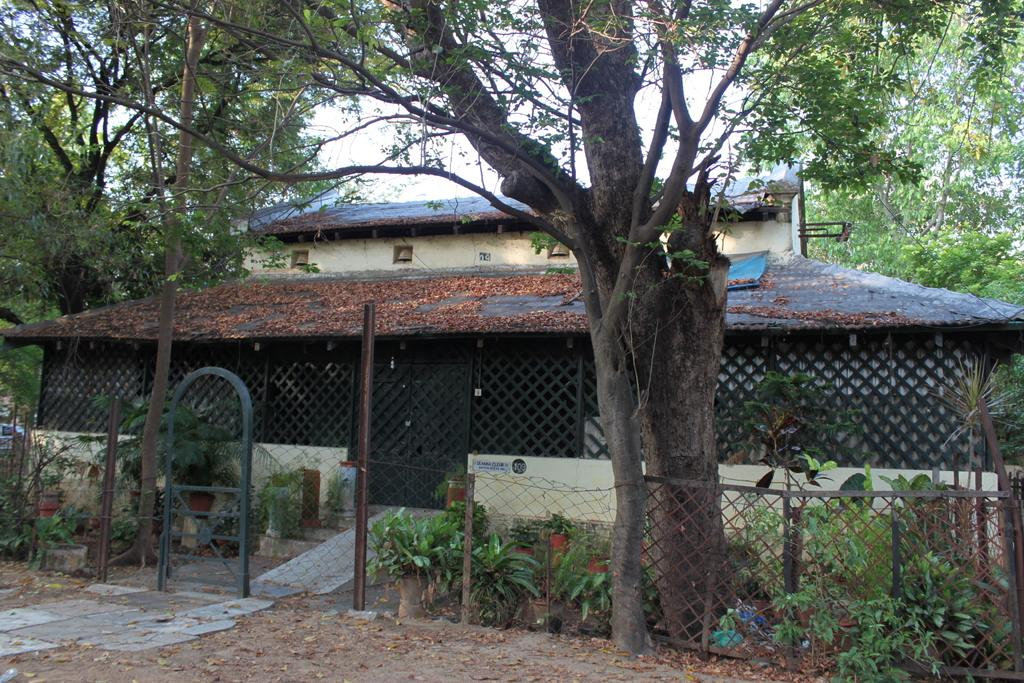What can be seen in the image that might be used for support or safety? There is a railing in the image that might be used for support or safety. What type of vegetation is present in the image? There are plants in the image, and they are in green color. What is visible in the background of the image? There is a building in the background of the image. What color is the sky in the image? The sky is visible in the image and is in white color. Where is the camp located in the image? There is no camp present in the image. What type of brush is used to paint the plants in the image? The image is a text, not a painting, so there is no brush used to create it. 